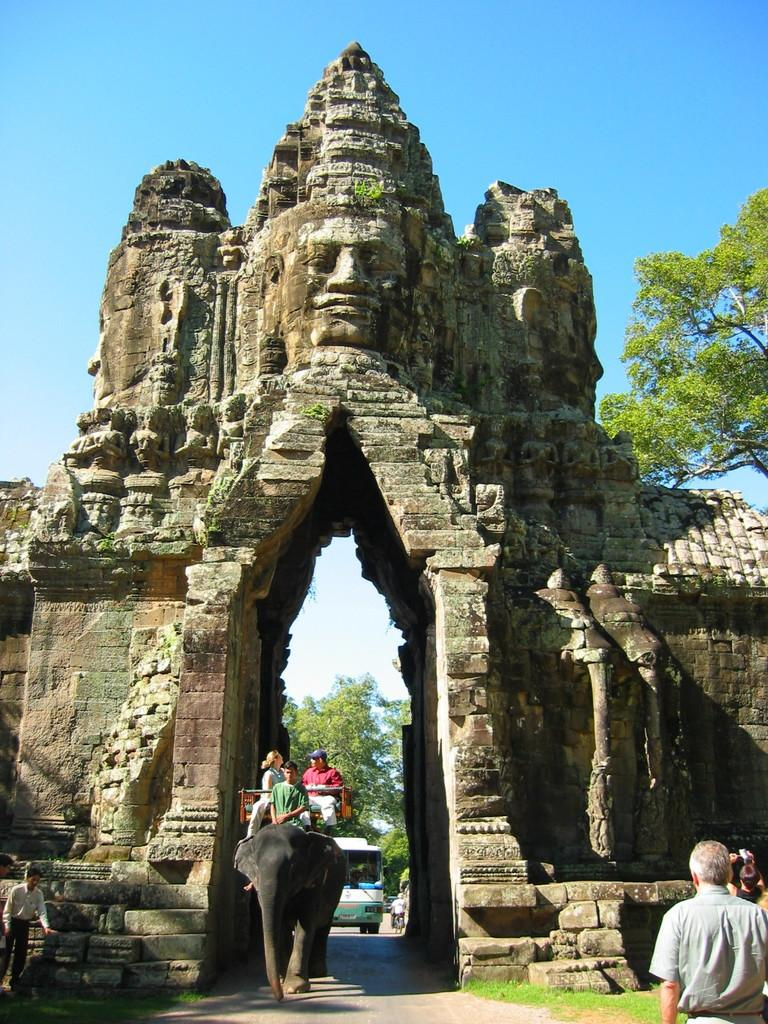What animal is present in the image? There is an elephant in the image. What are the people in the image doing? People are sitting on the elephant. What type of structure can be seen in the image? There is a huge building in the image. What type of oatmeal is being served at the vacation spot in the image? There is no mention of oatmeal or a vacation spot in the image; it features an elephant with people sitting on it and a huge building in the background. 